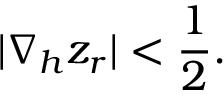Convert formula to latex. <formula><loc_0><loc_0><loc_500><loc_500>| \nabla _ { h } z _ { r } | < \frac { 1 } { 2 } .</formula> 